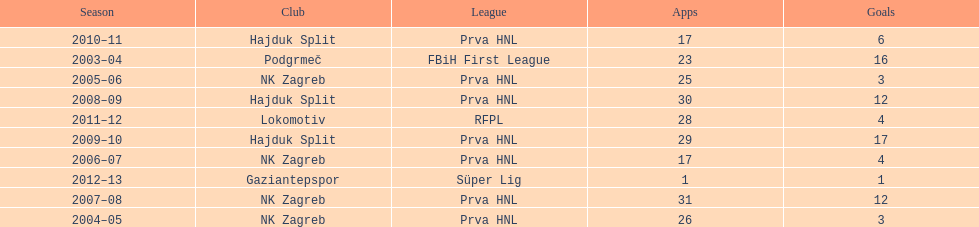Did ibricic score more or less goals in his 3 seasons with hajduk split when compared to his 4 seasons with nk zagreb? More. 